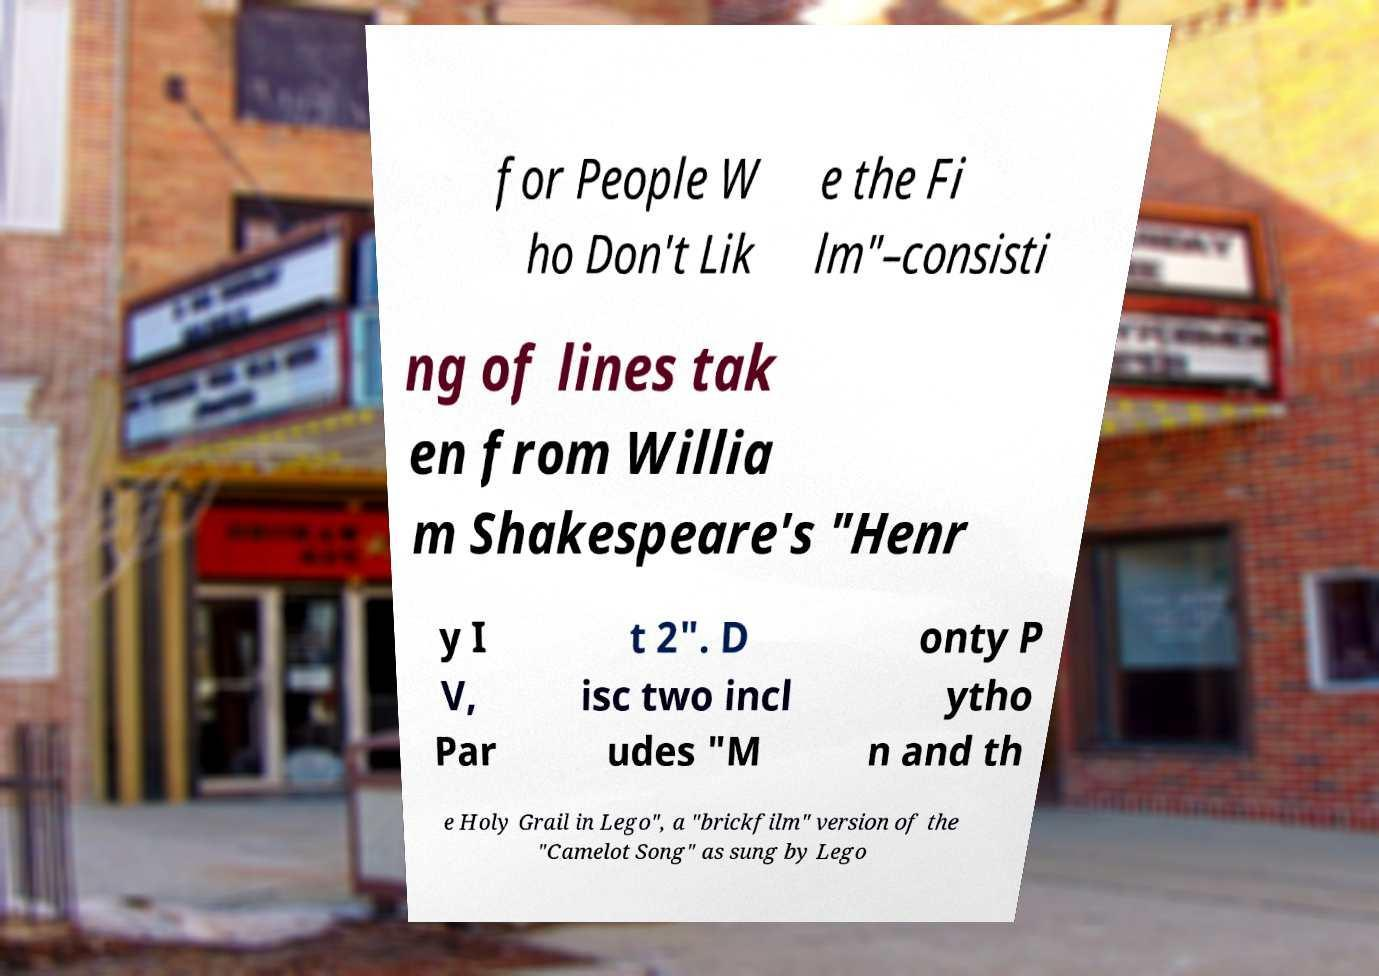What messages or text are displayed in this image? I need them in a readable, typed format. for People W ho Don't Lik e the Fi lm"–consisti ng of lines tak en from Willia m Shakespeare's "Henr y I V, Par t 2". D isc two incl udes "M onty P ytho n and th e Holy Grail in Lego", a "brickfilm" version of the "Camelot Song" as sung by Lego 